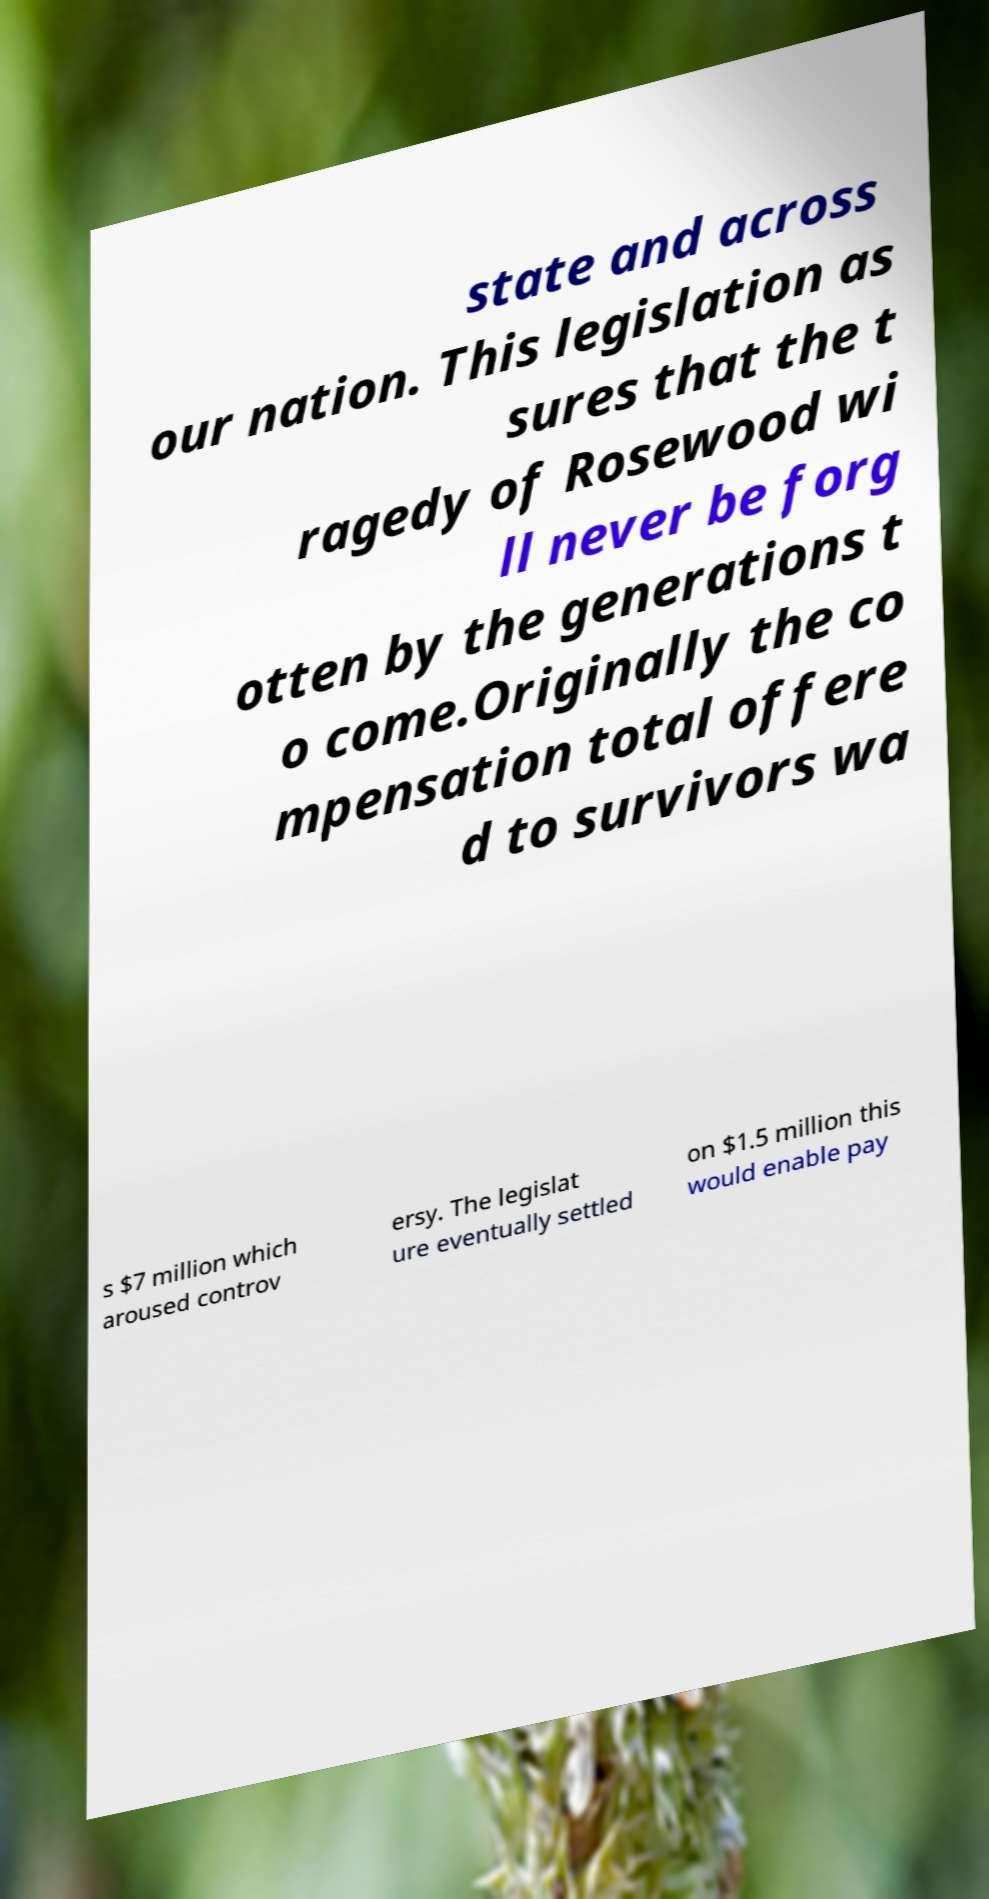Can you accurately transcribe the text from the provided image for me? state and across our nation. This legislation as sures that the t ragedy of Rosewood wi ll never be forg otten by the generations t o come.Originally the co mpensation total offere d to survivors wa s $7 million which aroused controv ersy. The legislat ure eventually settled on $1.5 million this would enable pay 